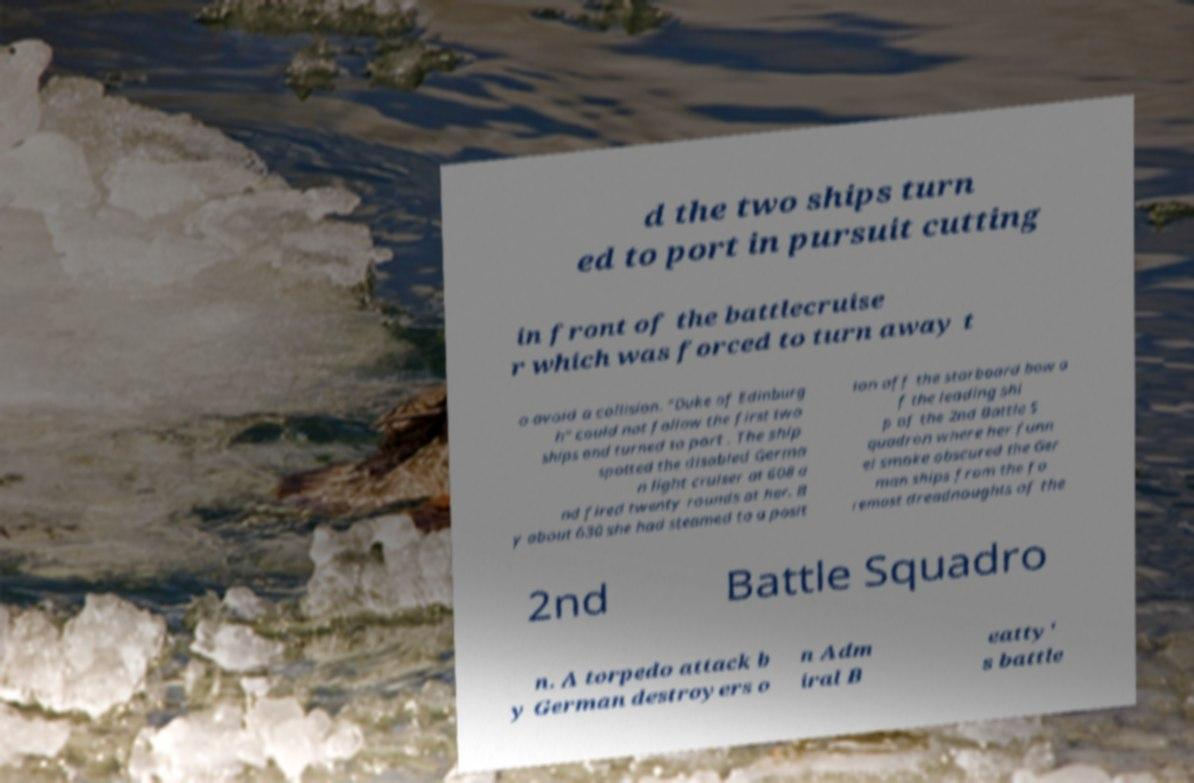I need the written content from this picture converted into text. Can you do that? d the two ships turn ed to port in pursuit cutting in front of the battlecruise r which was forced to turn away t o avoid a collision. "Duke of Edinburg h" could not follow the first two ships and turned to port . The ship spotted the disabled Germa n light cruiser at 608 a nd fired twenty rounds at her. B y about 630 she had steamed to a posit ion off the starboard bow o f the leading shi p of the 2nd Battle S quadron where her funn el smoke obscured the Ger man ships from the fo remost dreadnoughts of the 2nd Battle Squadro n. A torpedo attack b y German destroyers o n Adm iral B eatty' s battle 